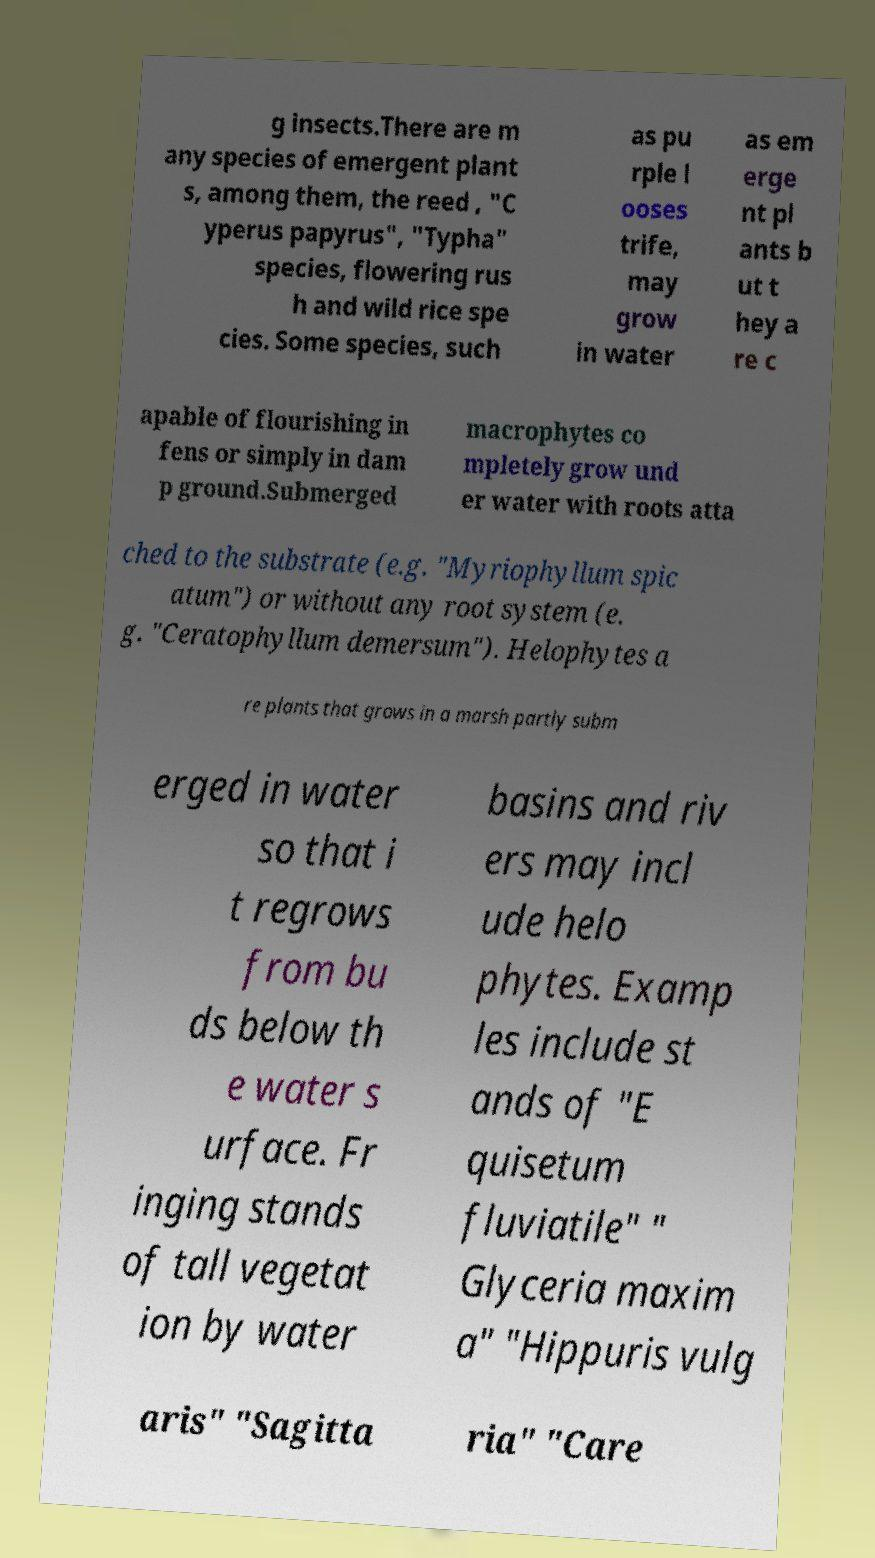There's text embedded in this image that I need extracted. Can you transcribe it verbatim? g insects.There are m any species of emergent plant s, among them, the reed , "C yperus papyrus", "Typha" species, flowering rus h and wild rice spe cies. Some species, such as pu rple l ooses trife, may grow in water as em erge nt pl ants b ut t hey a re c apable of flourishing in fens or simply in dam p ground.Submerged macrophytes co mpletely grow und er water with roots atta ched to the substrate (e.g. "Myriophyllum spic atum") or without any root system (e. g. "Ceratophyllum demersum"). Helophytes a re plants that grows in a marsh partly subm erged in water so that i t regrows from bu ds below th e water s urface. Fr inging stands of tall vegetat ion by water basins and riv ers may incl ude helo phytes. Examp les include st ands of "E quisetum fluviatile" " Glyceria maxim a" "Hippuris vulg aris" "Sagitta ria" "Care 